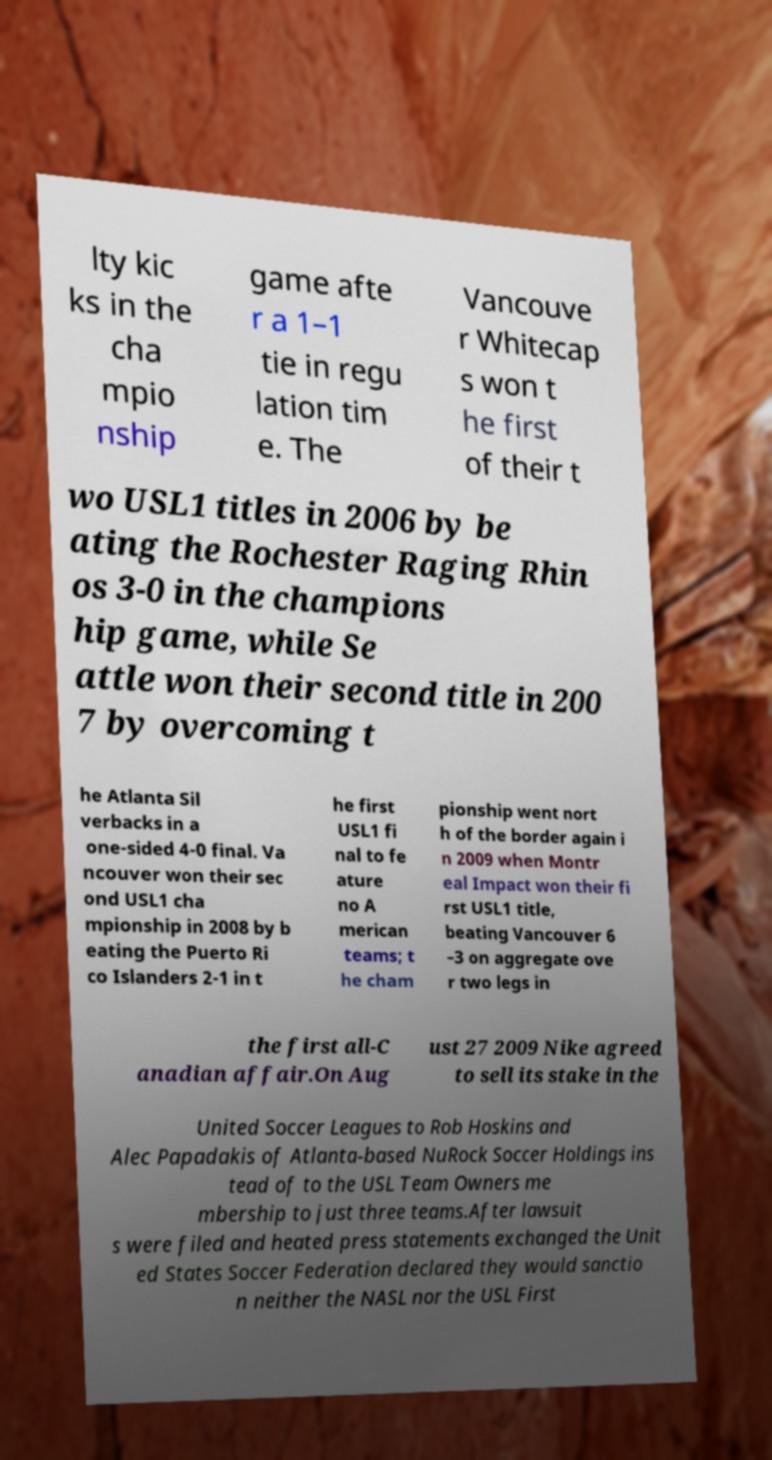Can you read and provide the text displayed in the image?This photo seems to have some interesting text. Can you extract and type it out for me? lty kic ks in the cha mpio nship game afte r a 1–1 tie in regu lation tim e. The Vancouve r Whitecap s won t he first of their t wo USL1 titles in 2006 by be ating the Rochester Raging Rhin os 3-0 in the champions hip game, while Se attle won their second title in 200 7 by overcoming t he Atlanta Sil verbacks in a one-sided 4-0 final. Va ncouver won their sec ond USL1 cha mpionship in 2008 by b eating the Puerto Ri co Islanders 2-1 in t he first USL1 fi nal to fe ature no A merican teams; t he cham pionship went nort h of the border again i n 2009 when Montr eal Impact won their fi rst USL1 title, beating Vancouver 6 –3 on aggregate ove r two legs in the first all-C anadian affair.On Aug ust 27 2009 Nike agreed to sell its stake in the United Soccer Leagues to Rob Hoskins and Alec Papadakis of Atlanta-based NuRock Soccer Holdings ins tead of to the USL Team Owners me mbership to just three teams.After lawsuit s were filed and heated press statements exchanged the Unit ed States Soccer Federation declared they would sanctio n neither the NASL nor the USL First 